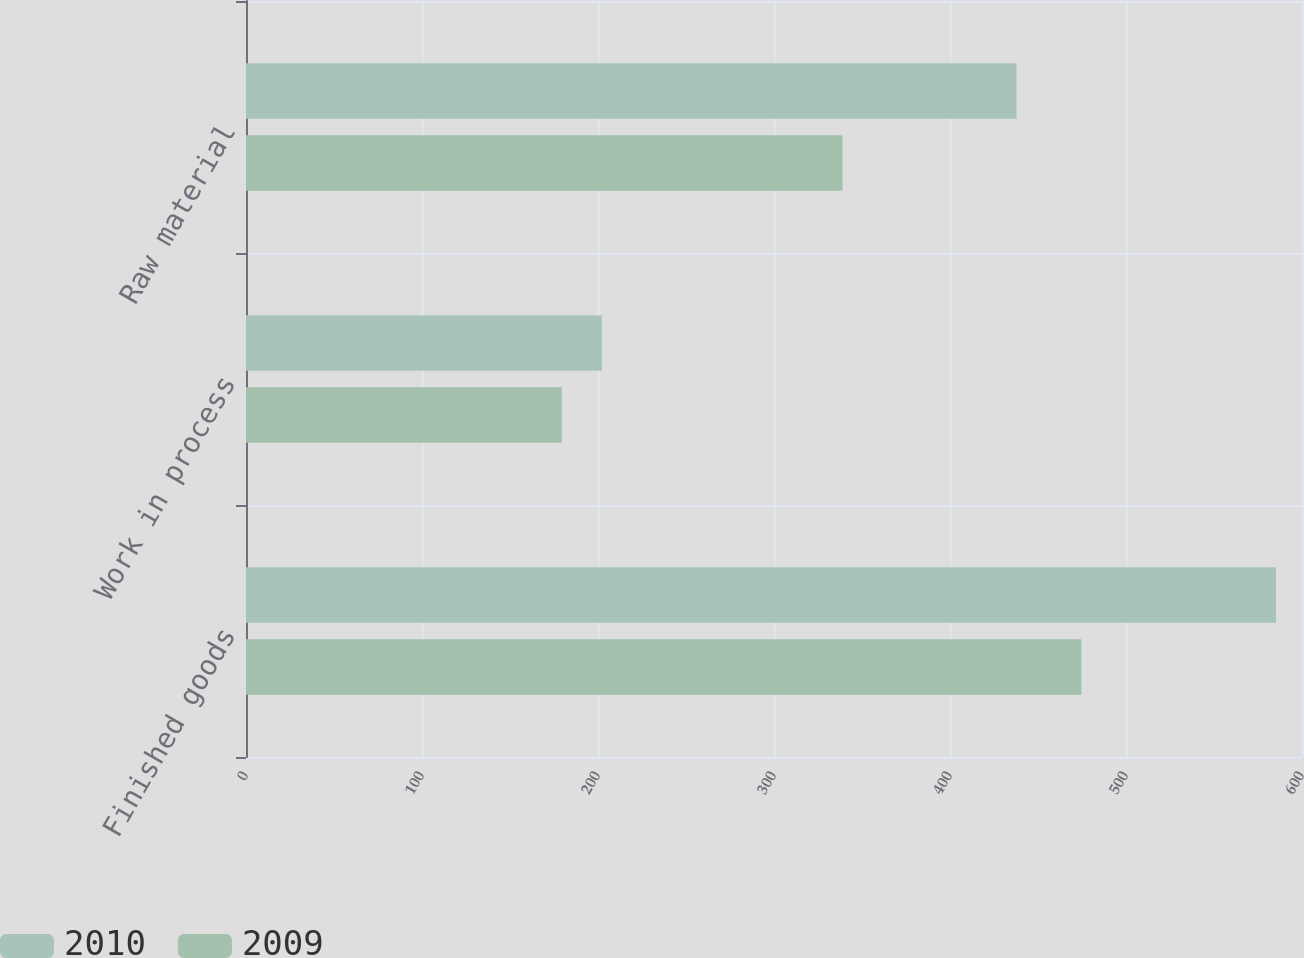Convert chart to OTSL. <chart><loc_0><loc_0><loc_500><loc_500><stacked_bar_chart><ecel><fcel>Finished goods<fcel>Work in process<fcel>Raw material<nl><fcel>2010<fcel>585.2<fcel>202.2<fcel>437.8<nl><fcel>2009<fcel>474.7<fcel>179.4<fcel>338.9<nl></chart> 